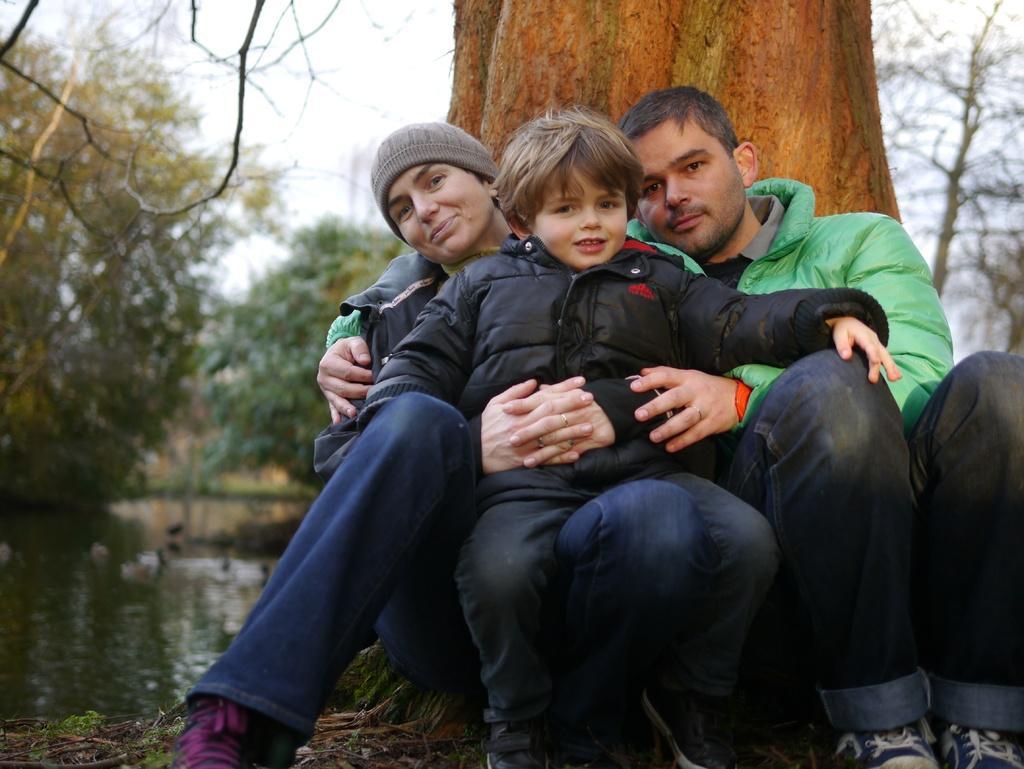Please provide a concise description of this image. There is a person wearing a cap and holding a child who is in black color jacket, sitting. Beside this person, there is another person in green color jacket sitting. Beside them, there is a tree. In the background, there is water, there are trees and there is sky. 